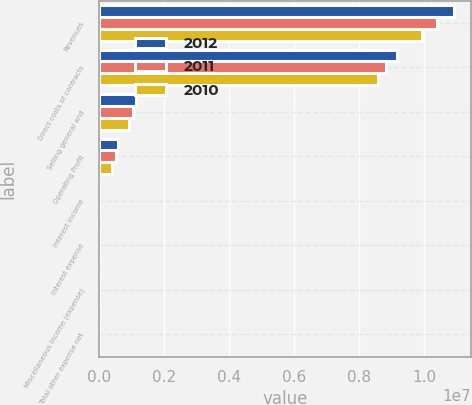<chart> <loc_0><loc_0><loc_500><loc_500><stacked_bar_chart><ecel><fcel>Revenues<fcel>Direct costs of contracts<fcel>Selling general and<fcel>Operating Profit<fcel>Interest income<fcel>Interest expense<fcel>Miscellaneous income (expense)<fcel>Total other expense net<nl><fcel>2012<fcel>1.08938e+07<fcel>9.16679e+06<fcel>1.13092e+06<fcel>596073<fcel>6049<fcel>11686<fcel>3392<fcel>2737<nl><fcel>2011<fcel>1.03817e+07<fcel>8.82217e+06<fcel>1.04058e+06<fcel>518918<fcel>4917<fcel>8799<fcel>1625<fcel>2257<nl><fcel>2010<fcel>9.91552e+06<fcel>8.58291e+06<fcel>932522<fcel>400083<fcel>4791<fcel>9874<fcel>3066<fcel>8149<nl></chart> 